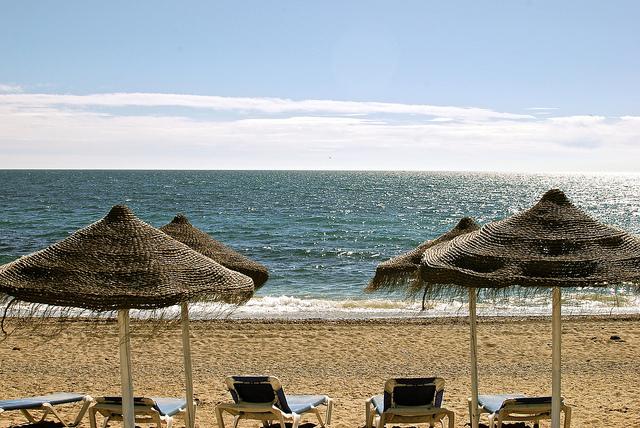How many people can sit in the lounge chairs?
Be succinct. 5. Are the umbrellas made of straw?
Give a very brief answer. Yes. Is it a windy day?
Keep it brief. Yes. 